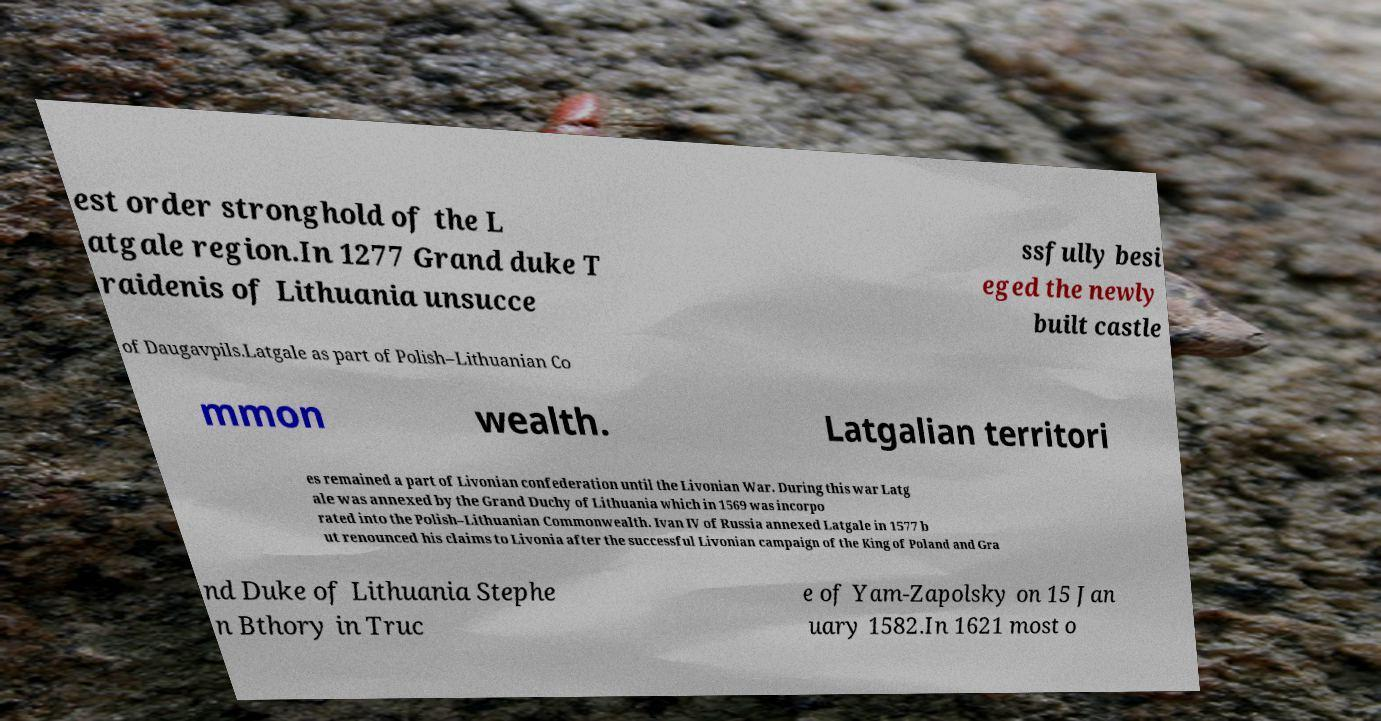Can you read and provide the text displayed in the image?This photo seems to have some interesting text. Can you extract and type it out for me? est order stronghold of the L atgale region.In 1277 Grand duke T raidenis of Lithuania unsucce ssfully besi eged the newly built castle of Daugavpils.Latgale as part of Polish–Lithuanian Co mmon wealth. Latgalian territori es remained a part of Livonian confederation until the Livonian War. During this war Latg ale was annexed by the Grand Duchy of Lithuania which in 1569 was incorpo rated into the Polish–Lithuanian Commonwealth. Ivan IV of Russia annexed Latgale in 1577 b ut renounced his claims to Livonia after the successful Livonian campaign of the King of Poland and Gra nd Duke of Lithuania Stephe n Bthory in Truc e of Yam-Zapolsky on 15 Jan uary 1582.In 1621 most o 